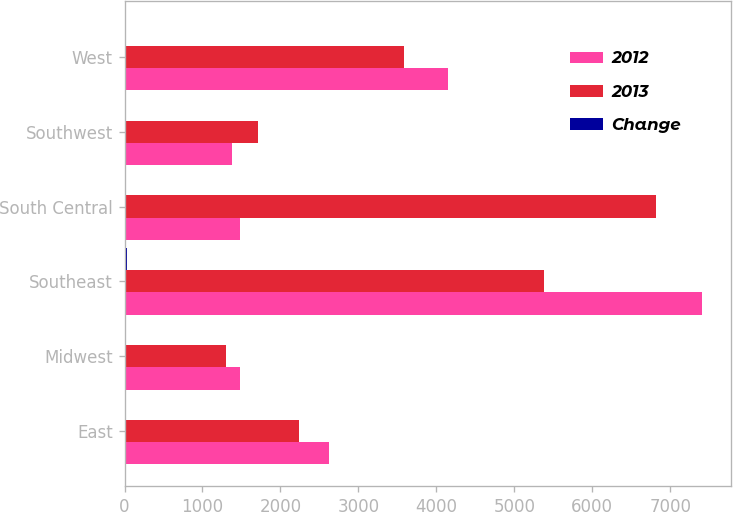<chart> <loc_0><loc_0><loc_500><loc_500><stacked_bar_chart><ecel><fcel>East<fcel>Midwest<fcel>Southeast<fcel>South Central<fcel>Southwest<fcel>West<nl><fcel>2012<fcel>2624<fcel>1480<fcel>7408<fcel>1480<fcel>1381<fcel>4153<nl><fcel>2013<fcel>2244<fcel>1301<fcel>5378<fcel>6822<fcel>1715<fcel>3588<nl><fcel>Change<fcel>17<fcel>14<fcel>38<fcel>18<fcel>19<fcel>16<nl></chart> 